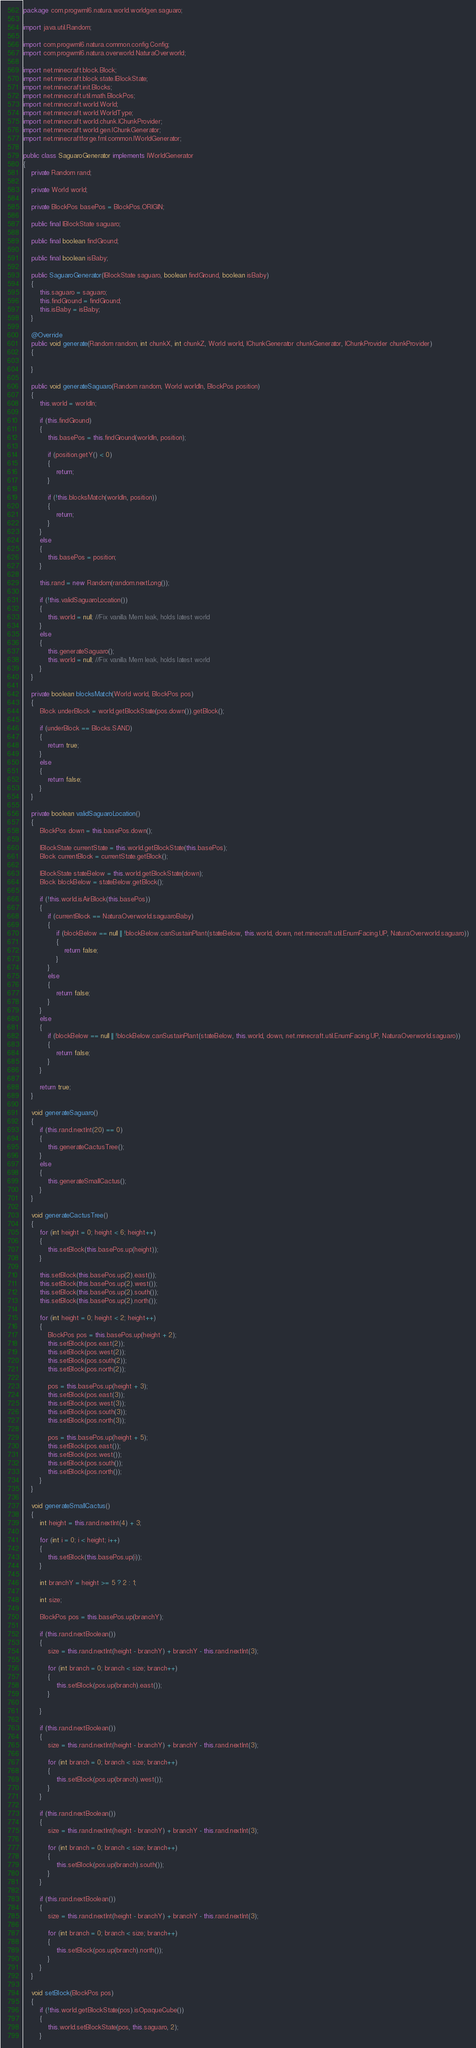<code> <loc_0><loc_0><loc_500><loc_500><_Java_>package com.progwml6.natura.world.worldgen.saguaro;

import java.util.Random;

import com.progwml6.natura.common.config.Config;
import com.progwml6.natura.overworld.NaturaOverworld;

import net.minecraft.block.Block;
import net.minecraft.block.state.IBlockState;
import net.minecraft.init.Blocks;
import net.minecraft.util.math.BlockPos;
import net.minecraft.world.World;
import net.minecraft.world.WorldType;
import net.minecraft.world.chunk.IChunkProvider;
import net.minecraft.world.gen.IChunkGenerator;
import net.minecraftforge.fml.common.IWorldGenerator;

public class SaguaroGenerator implements IWorldGenerator
{
    private Random rand;

    private World world;

    private BlockPos basePos = BlockPos.ORIGIN;

    public final IBlockState saguaro;

    public final boolean findGround;

    public final boolean isBaby;

    public SaguaroGenerator(IBlockState saguaro, boolean findGround, boolean isBaby)
    {
        this.saguaro = saguaro;
        this.findGround = findGround;
        this.isBaby = isBaby;
    }

    @Override
    public void generate(Random random, int chunkX, int chunkZ, World world, IChunkGenerator chunkGenerator, IChunkProvider chunkProvider)
    {

    }

    public void generateSaguaro(Random random, World worldIn, BlockPos position)
    {
        this.world = worldIn;

        if (this.findGround)
        {
            this.basePos = this.findGround(worldIn, position);

            if (position.getY() < 0)
            {
                return;
            }

            if (!this.blocksMatch(worldIn, position))
            {
                return;
            }
        }
        else
        {
            this.basePos = position;
        }

        this.rand = new Random(random.nextLong());

        if (!this.validSaguaroLocation())
        {
            this.world = null; //Fix vanilla Mem leak, holds latest world
        }
        else
        {
            this.generateSaguaro();
            this.world = null; //Fix vanilla Mem leak, holds latest world
        }
    }

    private boolean blocksMatch(World world, BlockPos pos)
    {
        Block underBlock = world.getBlockState(pos.down()).getBlock();

        if (underBlock == Blocks.SAND)
        {
            return true;
        }
        else
        {
            return false;
        }
    }

    private boolean validSaguaroLocation()
    {
        BlockPos down = this.basePos.down();

        IBlockState currentState = this.world.getBlockState(this.basePos);
        Block currentBlock = currentState.getBlock();

        IBlockState stateBelow = this.world.getBlockState(down);
        Block blockBelow = stateBelow.getBlock();

        if (!this.world.isAirBlock(this.basePos))
        {
            if (currentBlock == NaturaOverworld.saguaroBaby)
            {
                if (blockBelow == null || !blockBelow.canSustainPlant(stateBelow, this.world, down, net.minecraft.util.EnumFacing.UP, NaturaOverworld.saguaro))
                {
                    return false;
                }
            }
            else
            {
                return false;
            }
        }
        else
        {
            if (blockBelow == null || !blockBelow.canSustainPlant(stateBelow, this.world, down, net.minecraft.util.EnumFacing.UP, NaturaOverworld.saguaro))
            {
                return false;
            }
        }

        return true;
    }

    void generateSaguaro()
    {
        if (this.rand.nextInt(20) == 0)
        {
            this.generateCactusTree();
        }
        else
        {
            this.generateSmallCactus();
        }
    }

    void generateCactusTree()
    {
        for (int height = 0; height < 6; height++)
        {
            this.setBlock(this.basePos.up(height));
        }

        this.setBlock(this.basePos.up(2).east());
        this.setBlock(this.basePos.up(2).west());
        this.setBlock(this.basePos.up(2).south());
        this.setBlock(this.basePos.up(2).north());

        for (int height = 0; height < 2; height++)
        {
            BlockPos pos = this.basePos.up(height + 2);
            this.setBlock(pos.east(2));
            this.setBlock(pos.west(2));
            this.setBlock(pos.south(2));
            this.setBlock(pos.north(2));

            pos = this.basePos.up(height + 3);
            this.setBlock(pos.east(3));
            this.setBlock(pos.west(3));
            this.setBlock(pos.south(3));
            this.setBlock(pos.north(3));

            pos = this.basePos.up(height + 5);
            this.setBlock(pos.east());
            this.setBlock(pos.west());
            this.setBlock(pos.south());
            this.setBlock(pos.north());
        }
    }

    void generateSmallCactus()
    {
        int height = this.rand.nextInt(4) + 3;

        for (int i = 0; i < height; i++)
        {
            this.setBlock(this.basePos.up(i));
        }

        int branchY = height >= 5 ? 2 : 1;

        int size;

        BlockPos pos = this.basePos.up(branchY);

        if (this.rand.nextBoolean())
        {
            size = this.rand.nextInt(height - branchY) + branchY - this.rand.nextInt(3);

            for (int branch = 0; branch < size; branch++)
            {
                this.setBlock(pos.up(branch).east());
            }

        }

        if (this.rand.nextBoolean())
        {
            size = this.rand.nextInt(height - branchY) + branchY - this.rand.nextInt(3);

            for (int branch = 0; branch < size; branch++)
            {
                this.setBlock(pos.up(branch).west());
            }
        }

        if (this.rand.nextBoolean())
        {
            size = this.rand.nextInt(height - branchY) + branchY - this.rand.nextInt(3);

            for (int branch = 0; branch < size; branch++)
            {
                this.setBlock(pos.up(branch).south());
            }
        }

        if (this.rand.nextBoolean())
        {
            size = this.rand.nextInt(height - branchY) + branchY - this.rand.nextInt(3);

            for (int branch = 0; branch < size; branch++)
            {
                this.setBlock(pos.up(branch).north());
            }
        }
    }

    void setBlock(BlockPos pos)
    {
        if (!this.world.getBlockState(pos).isOpaqueCube())
        {
            this.world.setBlockState(pos, this.saguaro, 2);
        }</code> 